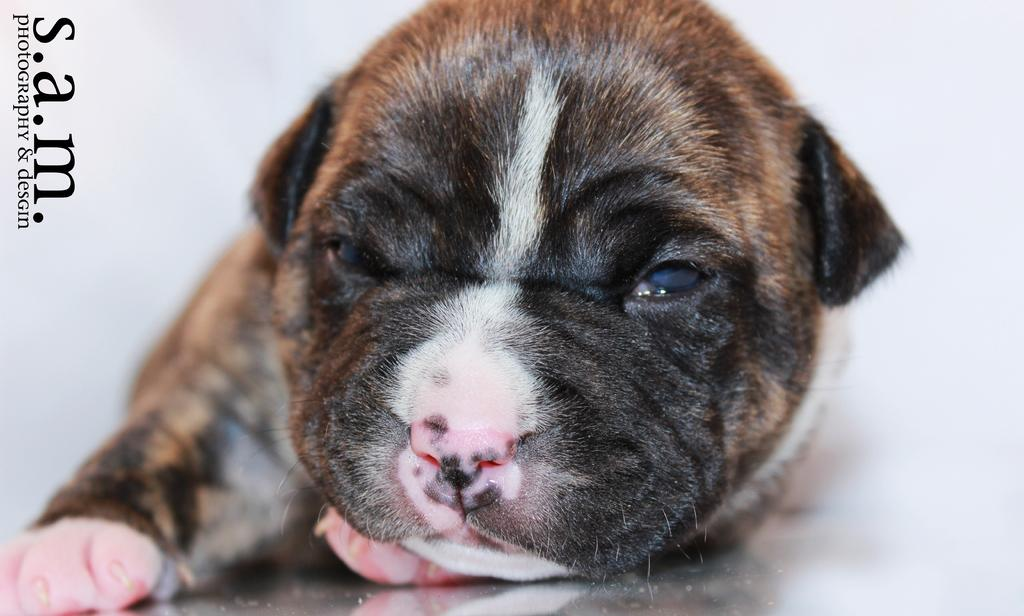What animal can be seen in the image? There is a dog in the image. What is the dog doing in the image? The dog is lying on a surface. What color is the background of the image? The background of the image is white. Are there any visible marks or patterns in the image? Yes, there are watermarks in the top left side of the image. Can you see the dog's grandmother in the image? There is no grandmother present in the image, only the dog can be seen. 